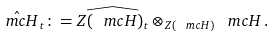<formula> <loc_0><loc_0><loc_500><loc_500>\hat { \ m c H } _ { t } \colon = \widehat { Z ( \ m c H ) _ { t } } \otimes _ { Z ( \ m c H ) } \ m c H \, .</formula> 